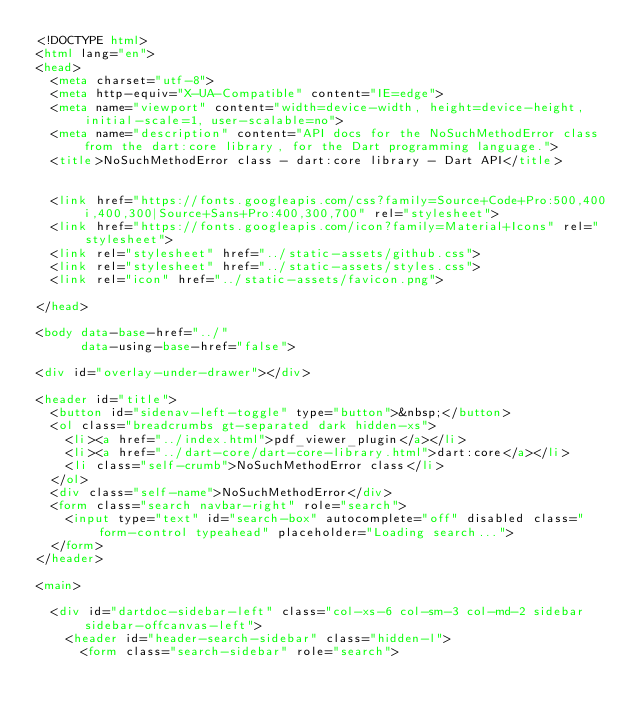<code> <loc_0><loc_0><loc_500><loc_500><_HTML_><!DOCTYPE html>
<html lang="en">
<head>
  <meta charset="utf-8">
  <meta http-equiv="X-UA-Compatible" content="IE=edge">
  <meta name="viewport" content="width=device-width, height=device-height, initial-scale=1, user-scalable=no">
  <meta name="description" content="API docs for the NoSuchMethodError class from the dart:core library, for the Dart programming language.">
  <title>NoSuchMethodError class - dart:core library - Dart API</title>

  
  <link href="https://fonts.googleapis.com/css?family=Source+Code+Pro:500,400i,400,300|Source+Sans+Pro:400,300,700" rel="stylesheet">
  <link href="https://fonts.googleapis.com/icon?family=Material+Icons" rel="stylesheet">
  <link rel="stylesheet" href="../static-assets/github.css">
  <link rel="stylesheet" href="../static-assets/styles.css">
  <link rel="icon" href="../static-assets/favicon.png">

</head>

<body data-base-href="../"
      data-using-base-href="false">

<div id="overlay-under-drawer"></div>

<header id="title">
  <button id="sidenav-left-toggle" type="button">&nbsp;</button>
  <ol class="breadcrumbs gt-separated dark hidden-xs">
    <li><a href="../index.html">pdf_viewer_plugin</a></li>
    <li><a href="../dart-core/dart-core-library.html">dart:core</a></li>
    <li class="self-crumb">NoSuchMethodError class</li>
  </ol>
  <div class="self-name">NoSuchMethodError</div>
  <form class="search navbar-right" role="search">
    <input type="text" id="search-box" autocomplete="off" disabled class="form-control typeahead" placeholder="Loading search...">
  </form>
</header>

<main>

  <div id="dartdoc-sidebar-left" class="col-xs-6 col-sm-3 col-md-2 sidebar sidebar-offcanvas-left">
    <header id="header-search-sidebar" class="hidden-l">
      <form class="search-sidebar" role="search"></code> 